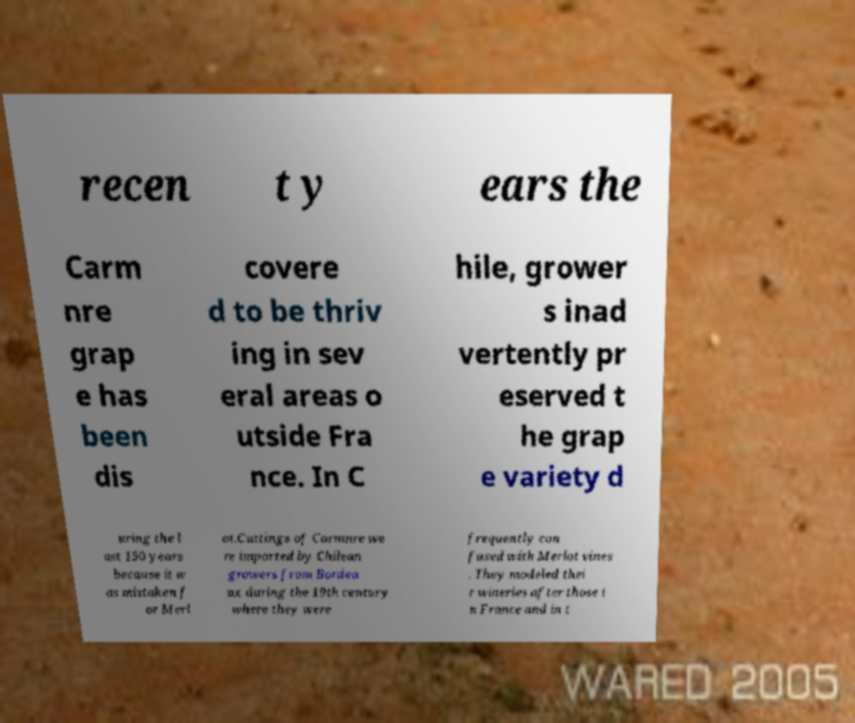For documentation purposes, I need the text within this image transcribed. Could you provide that? recen t y ears the Carm nre grap e has been dis covere d to be thriv ing in sev eral areas o utside Fra nce. In C hile, grower s inad vertently pr eserved t he grap e variety d uring the l ast 150 years because it w as mistaken f or Merl ot.Cuttings of Carmnre we re imported by Chilean growers from Bordea ux during the 19th century where they were frequently con fused with Merlot vines . They modeled thei r wineries after those i n France and in t 